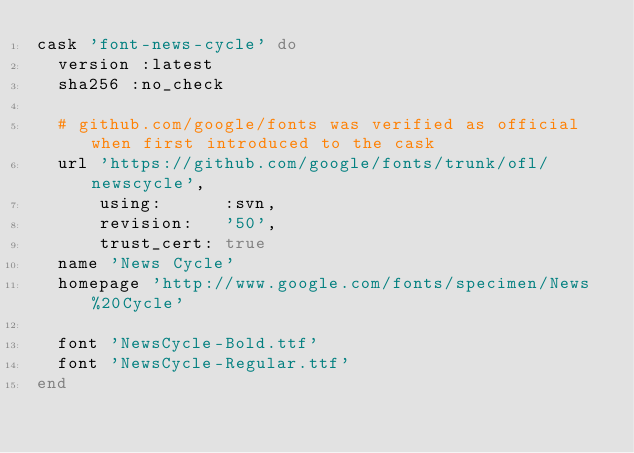<code> <loc_0><loc_0><loc_500><loc_500><_Ruby_>cask 'font-news-cycle' do
  version :latest
  sha256 :no_check

  # github.com/google/fonts was verified as official when first introduced to the cask
  url 'https://github.com/google/fonts/trunk/ofl/newscycle',
      using:      :svn,
      revision:   '50',
      trust_cert: true
  name 'News Cycle'
  homepage 'http://www.google.com/fonts/specimen/News%20Cycle'

  font 'NewsCycle-Bold.ttf'
  font 'NewsCycle-Regular.ttf'
end
</code> 